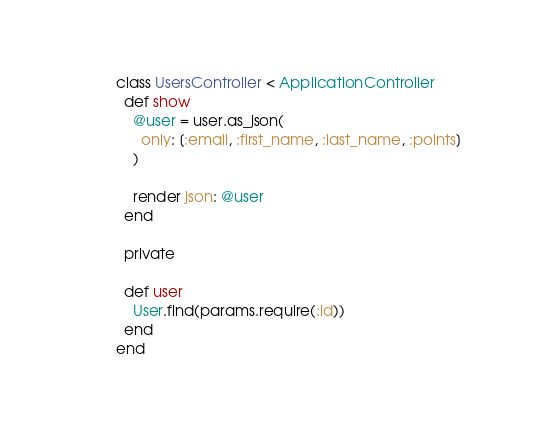Convert code to text. <code><loc_0><loc_0><loc_500><loc_500><_Ruby_>class UsersController < ApplicationController
  def show
    @user = user.as_json(
      only: [:email, :first_name, :last_name, :points]
    )

    render json: @user
  end

  private

  def user
    User.find(params.require(:id))
  end
end
</code> 